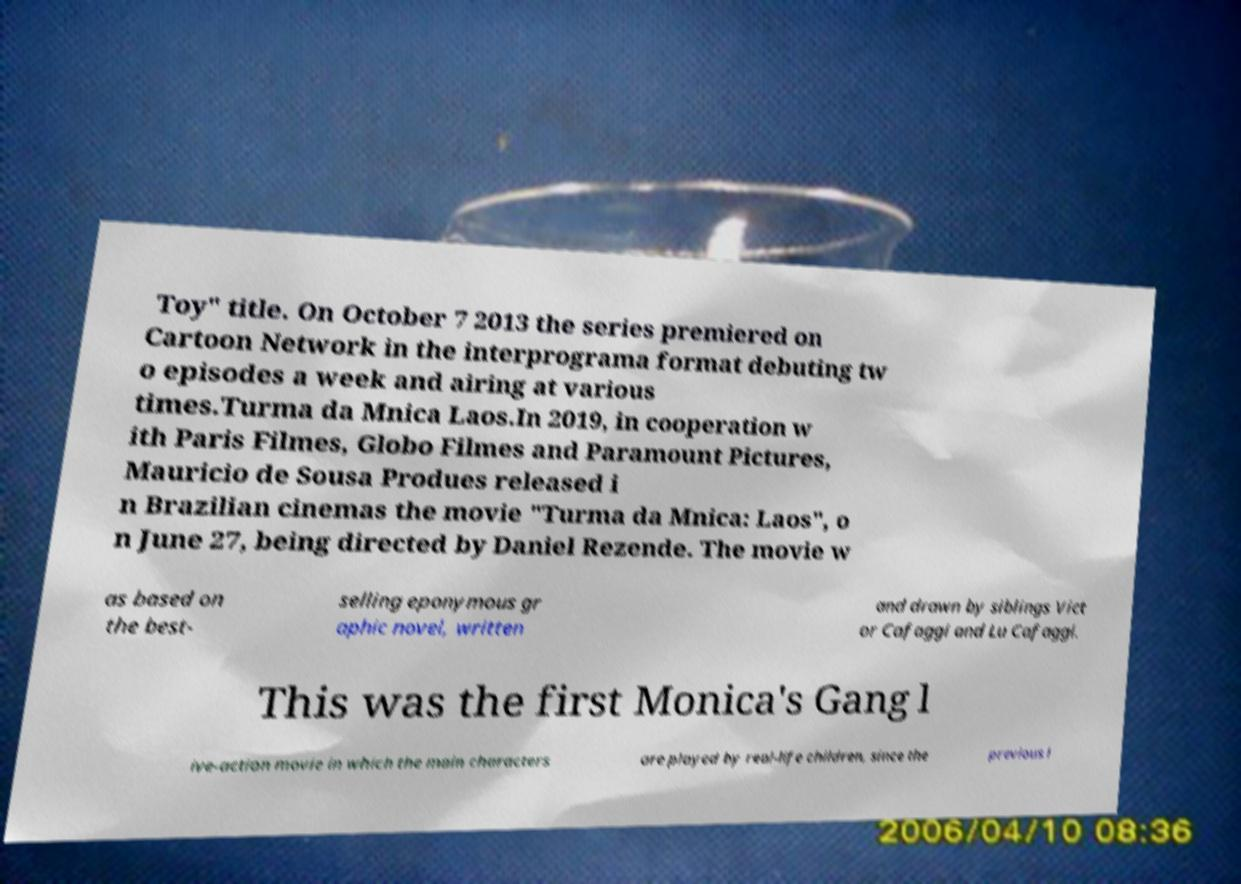Could you assist in decoding the text presented in this image and type it out clearly? Toy" title. On October 7 2013 the series premiered on Cartoon Network in the interprograma format debuting tw o episodes a week and airing at various times.Turma da Mnica Laos.In 2019, in cooperation w ith Paris Filmes, Globo Filmes and Paramount Pictures, Mauricio de Sousa Produes released i n Brazilian cinemas the movie "Turma da Mnica: Laos", o n June 27, being directed by Daniel Rezende. The movie w as based on the best- selling eponymous gr aphic novel, written and drawn by siblings Vict or Cafaggi and Lu Cafaggi. This was the first Monica's Gang l ive-action movie in which the main characters are played by real-life children, since the previous l 